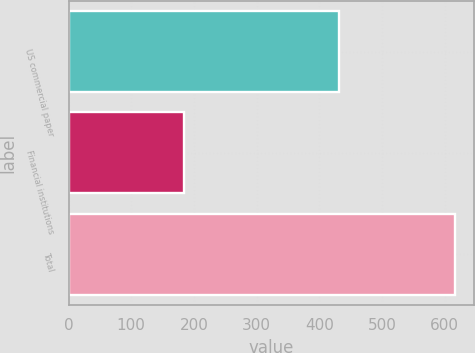Convert chart. <chart><loc_0><loc_0><loc_500><loc_500><bar_chart><fcel>US commercial paper<fcel>Financial institutions<fcel>Total<nl><fcel>432<fcel>183.8<fcel>615.8<nl></chart> 